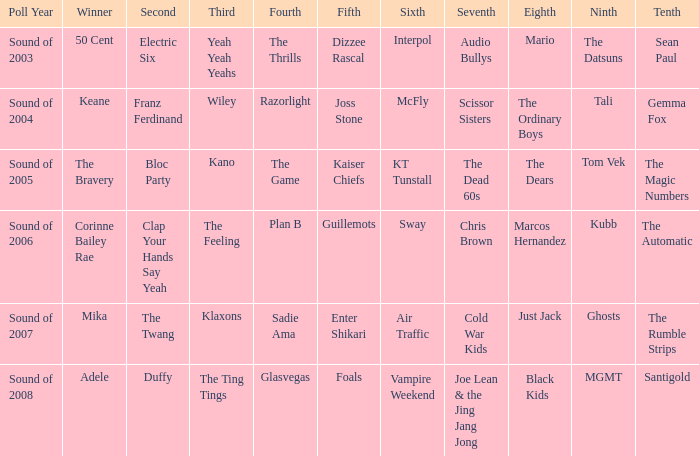When dizzee rascal is 5th, who was the winner? 50 Cent. 